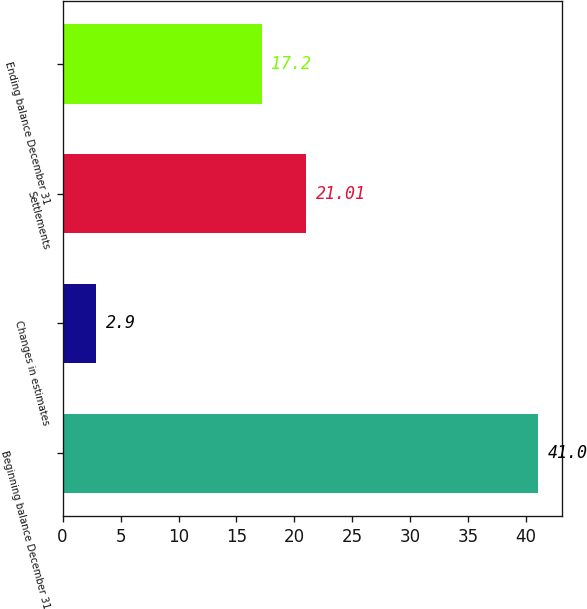<chart> <loc_0><loc_0><loc_500><loc_500><bar_chart><fcel>Beginning balance December 31<fcel>Changes in estimates<fcel>Settlements<fcel>Ending balance December 31<nl><fcel>41<fcel>2.9<fcel>21.01<fcel>17.2<nl></chart> 